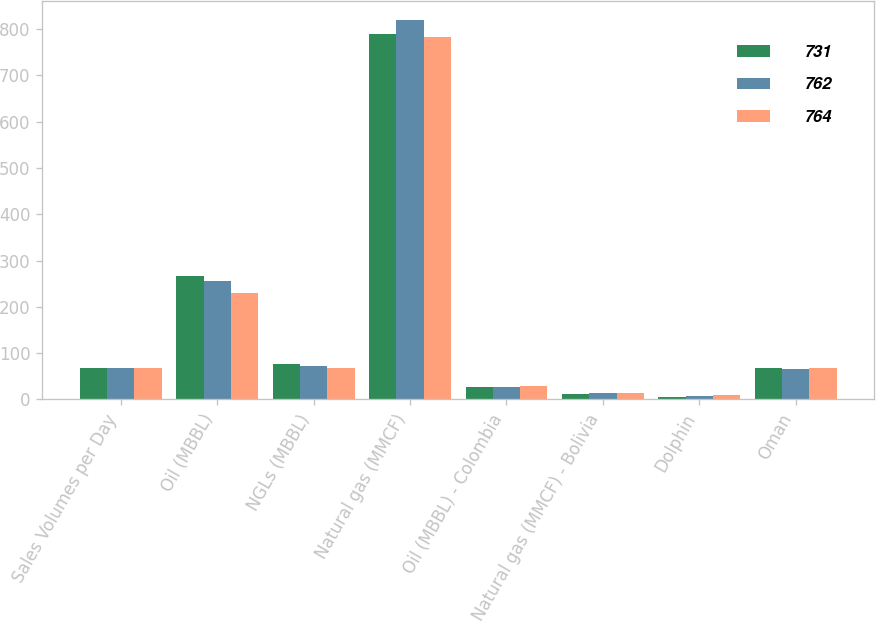Convert chart. <chart><loc_0><loc_0><loc_500><loc_500><stacked_bar_chart><ecel><fcel>Sales Volumes per Day<fcel>Oil (MBBL)<fcel>NGLs (MBBL)<fcel>Natural gas (MMCF)<fcel>Oil (MBBL) - Colombia<fcel>Natural gas (MMCF) - Bolivia<fcel>Dolphin<fcel>Oman<nl><fcel>731<fcel>68<fcel>266<fcel>77<fcel>789<fcel>27<fcel>12<fcel>6<fcel>68<nl><fcel>762<fcel>68<fcel>255<fcel>73<fcel>819<fcel>28<fcel>13<fcel>8<fcel>66<nl><fcel>764<fcel>68<fcel>230<fcel>69<fcel>782<fcel>29<fcel>15<fcel>9<fcel>69<nl></chart> 